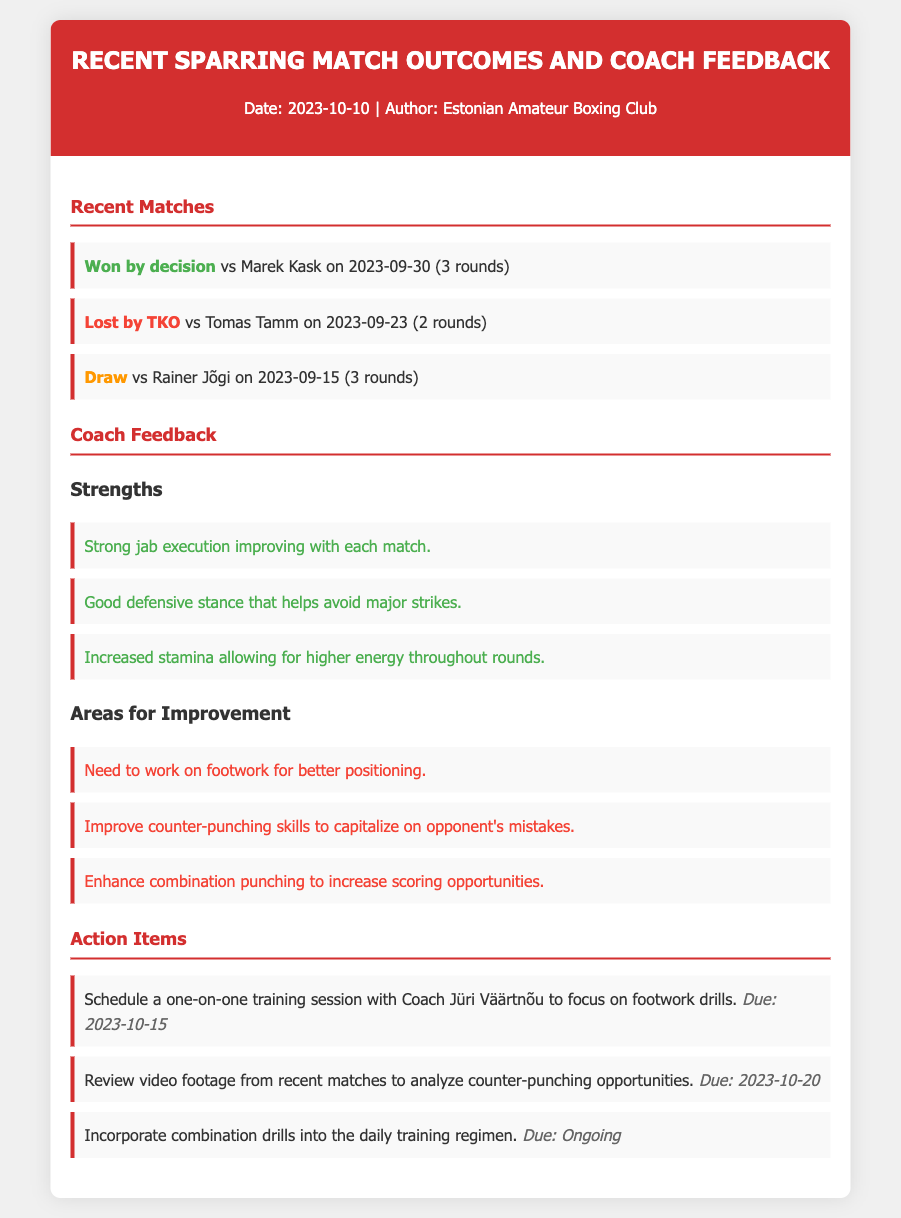What was the outcome of the match against Marek Kask? The outcome is listed as "Won by decision" in the matches section.
Answer: Won by decision When did the sparring match against Tomas Tamm occur? The date is provided next to the match outcome in the matches section, which is "2023-09-23."
Answer: 2023-09-23 What are the strengths noted by the coaches? The strengths include several items listed under the feedback section that focus on jab execution, defensive stance, and stamina.
Answer: Strong jab execution improving with each match How many matches are recorded in the memo? The number of matches can be counted from the list in the "Recent Matches" section which includes three entries.
Answer: 3 What is one area for improvement mentioned? The areas for improvement list several points, one of which needs to be chosen to answer the question.
Answer: Need to work on footwork for better positioning Who should the training session be scheduled with? The action item specifically mentions "Coach Jüri Väärtnõu" for the training session.
Answer: Coach Jüri Väärtnõu What is the due date for reviewing video footage? The due date is provided next to the related action item in the action items section as "2023-10-20."
Answer: 2023-10-20 What type of outcome was the sparring match against Rainer Jõgi? The type of outcome is indicated in the matches section with "Draw."
Answer: Draw What is being focused on during the one-on-one training session? The action item indicates that the focus during the session will be on footwork drills.
Answer: Footwork drills 